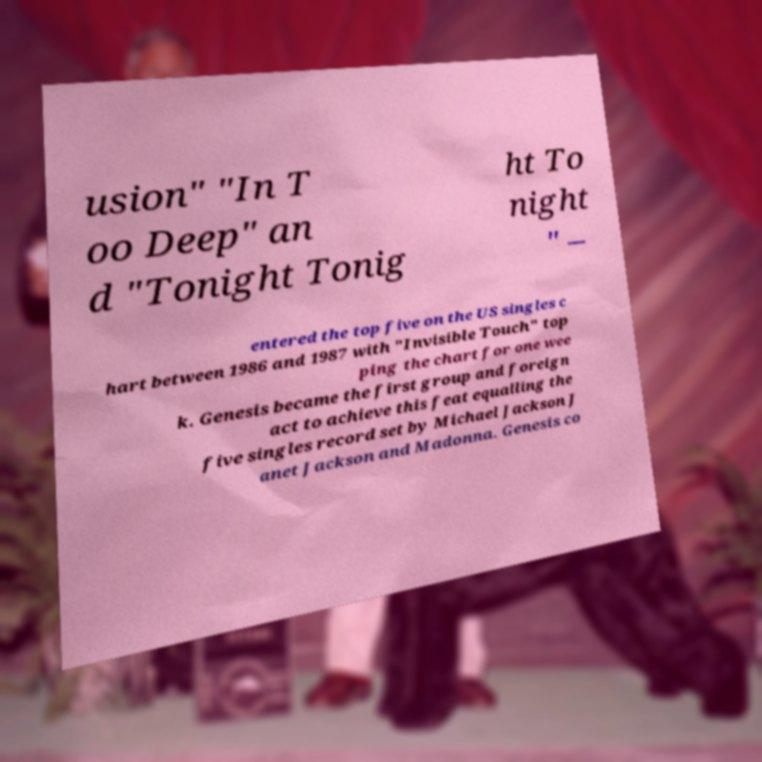For documentation purposes, I need the text within this image transcribed. Could you provide that? usion" "In T oo Deep" an d "Tonight Tonig ht To night " – entered the top five on the US singles c hart between 1986 and 1987 with "Invisible Touch" top ping the chart for one wee k. Genesis became the first group and foreign act to achieve this feat equalling the five singles record set by Michael Jackson J anet Jackson and Madonna. Genesis co 